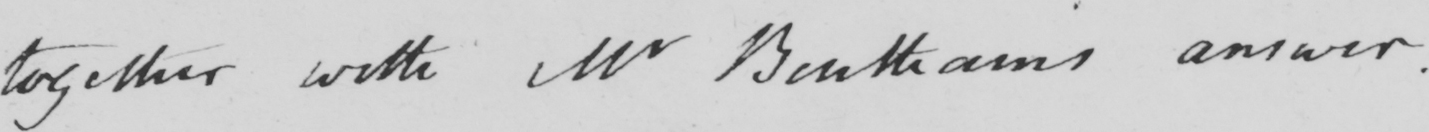Transcribe the text shown in this historical manuscript line. _  together with Mr Bentham ' s answer . 